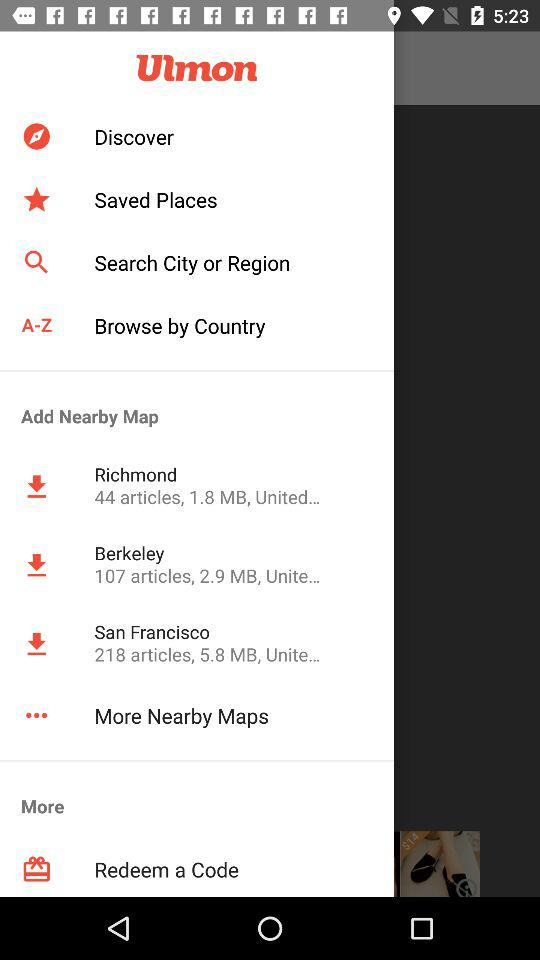What is the number of articles present in "Richmond"? The number of articles present in "Richmond" is 44. 